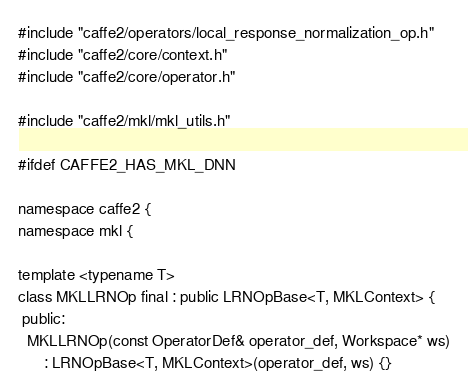<code> <loc_0><loc_0><loc_500><loc_500><_C++_>#include "caffe2/operators/local_response_normalization_op.h"
#include "caffe2/core/context.h"
#include "caffe2/core/operator.h"

#include "caffe2/mkl/mkl_utils.h"

#ifdef CAFFE2_HAS_MKL_DNN

namespace caffe2 {
namespace mkl {

template <typename T>
class MKLLRNOp final : public LRNOpBase<T, MKLContext> {
 public:
  MKLLRNOp(const OperatorDef& operator_def, Workspace* ws)
      : LRNOpBase<T, MKLContext>(operator_def, ws) {}
</code> 